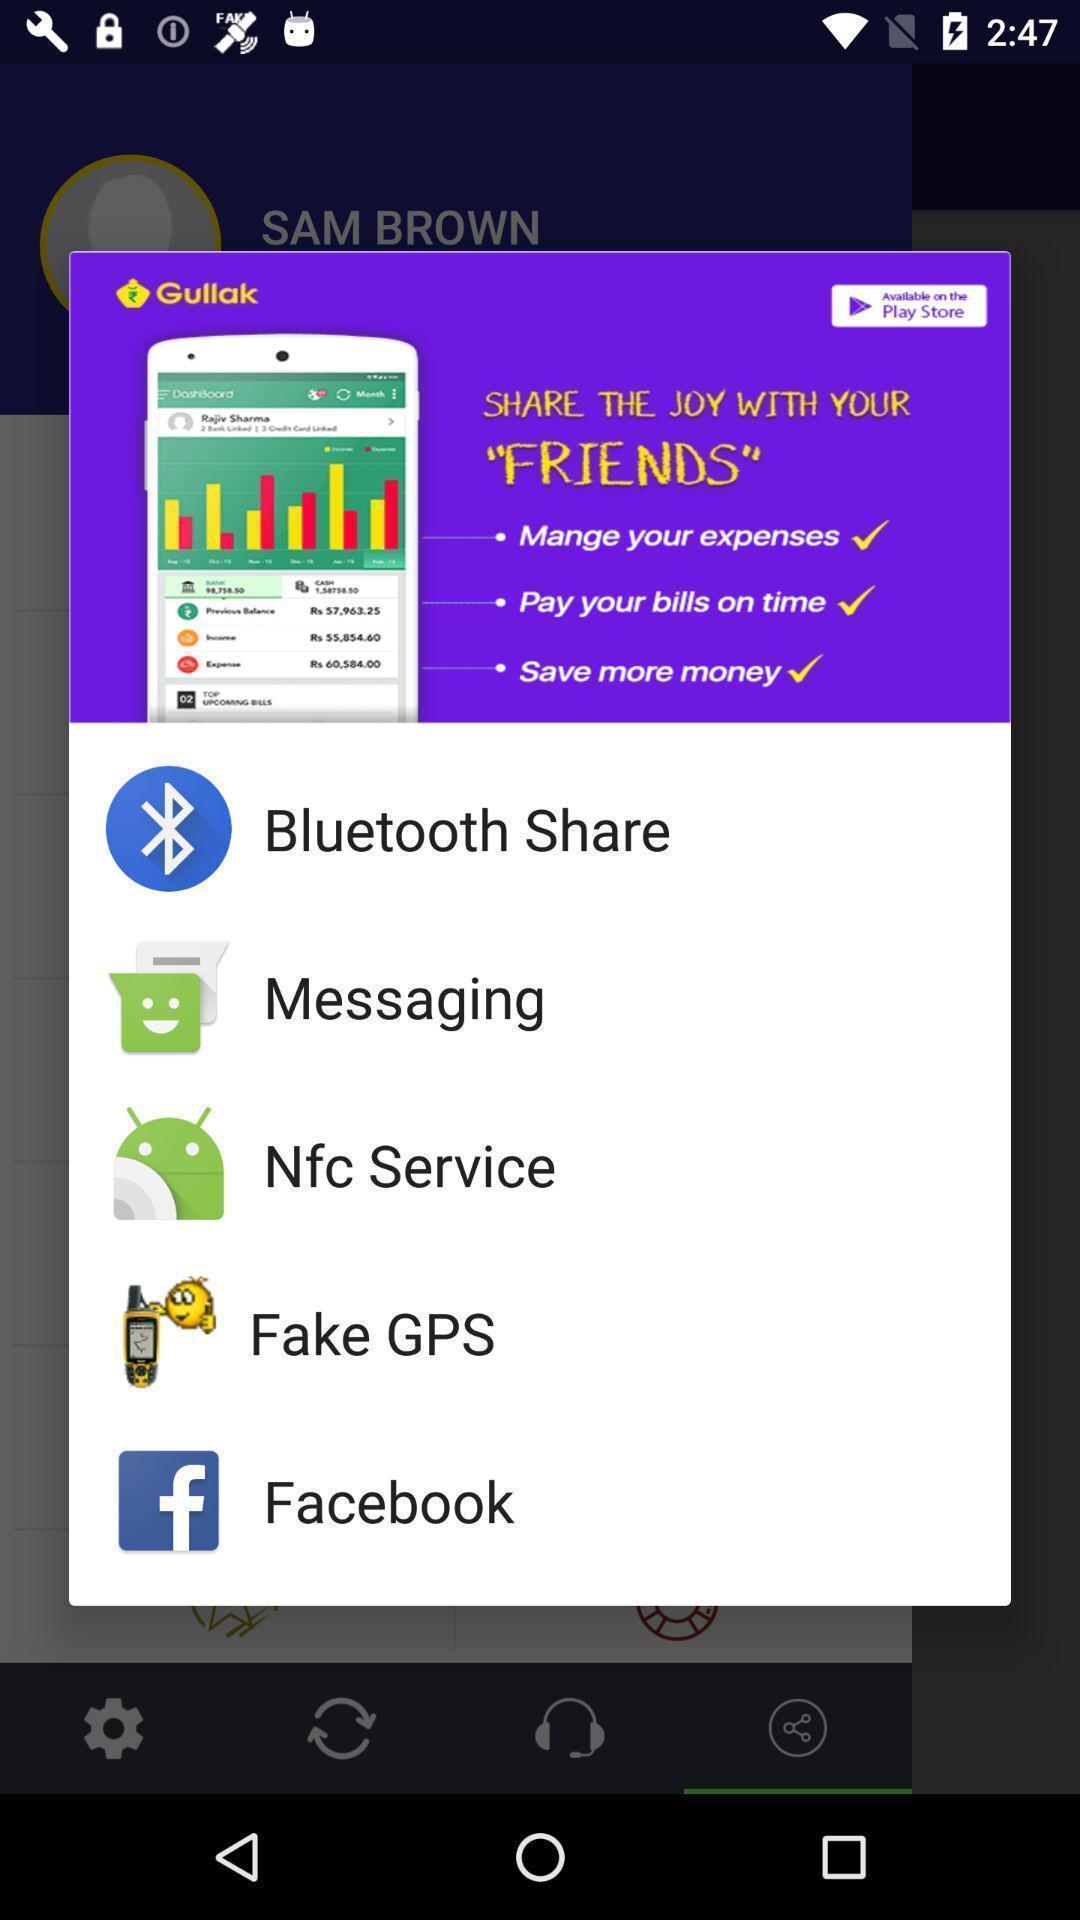Summarize the information in this screenshot. Pop-up screen displaying with application options. 